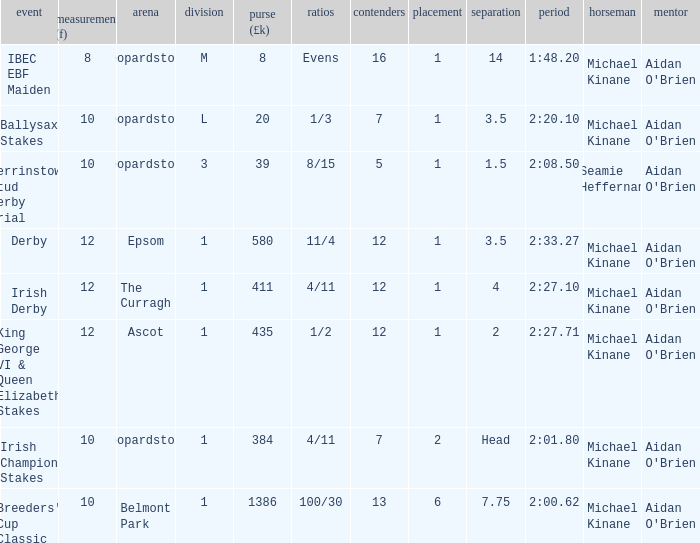Name the highest Dist (f) with Odds of 11/4 and a Placing larger than 1? None. 